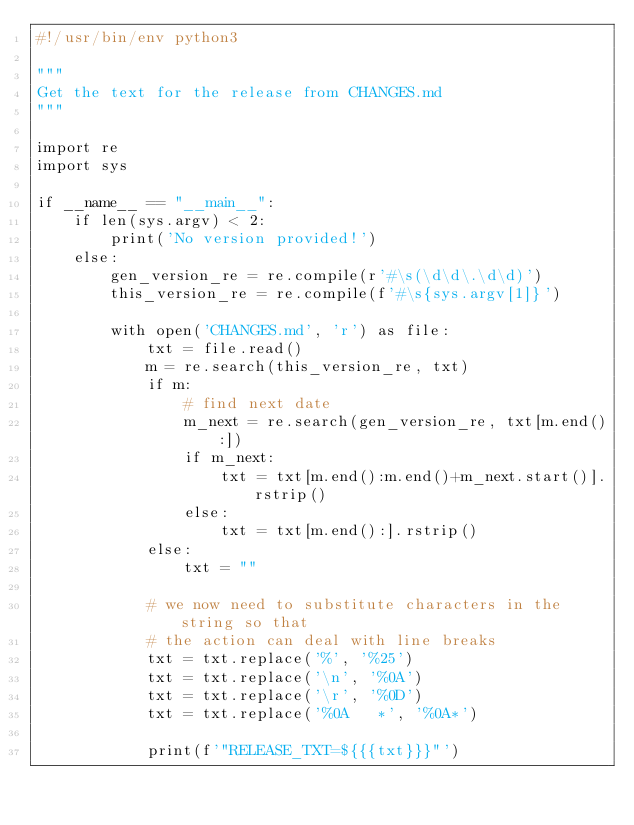Convert code to text. <code><loc_0><loc_0><loc_500><loc_500><_Python_>#!/usr/bin/env python3

"""
Get the text for the release from CHANGES.md
"""

import re
import sys

if __name__ == "__main__":
    if len(sys.argv) < 2:
        print('No version provided!')
    else:
        gen_version_re = re.compile(r'#\s(\d\d\.\d\d)')
        this_version_re = re.compile(f'#\s{sys.argv[1]}')

        with open('CHANGES.md', 'r') as file:
            txt = file.read()
            m = re.search(this_version_re, txt)
            if m:
                # find next date
                m_next = re.search(gen_version_re, txt[m.end():])
                if m_next:
                    txt = txt[m.end():m.end()+m_next.start()].rstrip()
                else:
                    txt = txt[m.end():].rstrip()
            else:
                txt = ""

            # we now need to substitute characters in the string so that
            # the action can deal with line breaks
            txt = txt.replace('%', '%25')
            txt = txt.replace('\n', '%0A')
            txt = txt.replace('\r', '%0D')
            txt = txt.replace('%0A   *', '%0A*')

            print(f'"RELEASE_TXT=${{{txt}}}"')
</code> 